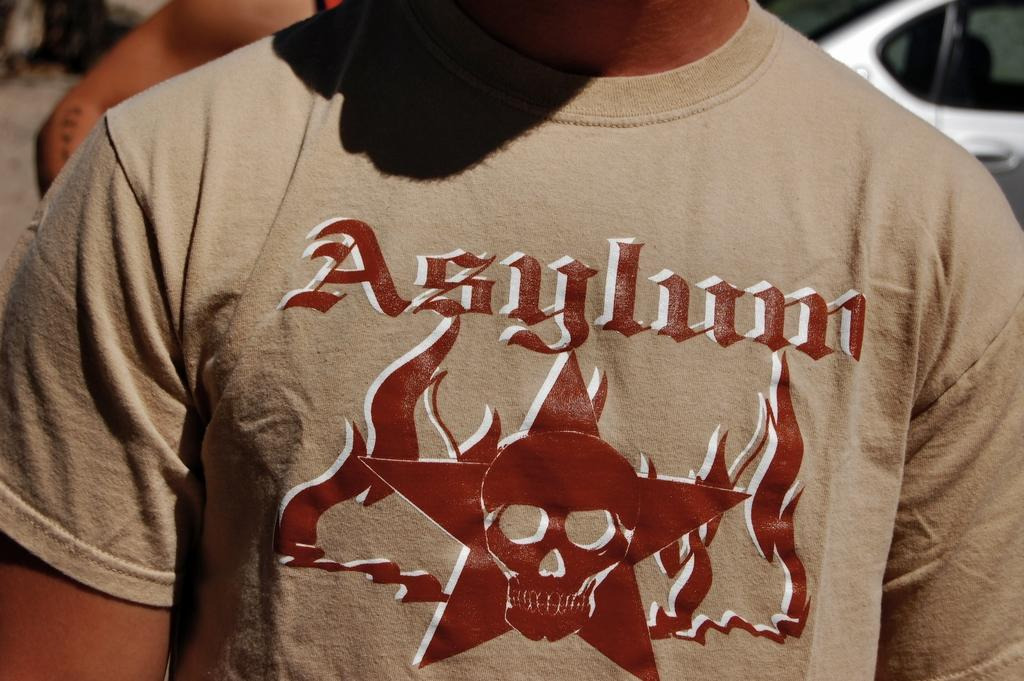<image>
Present a compact description of the photo's key features. A tshirt with a skull and the word Asylum on it. 